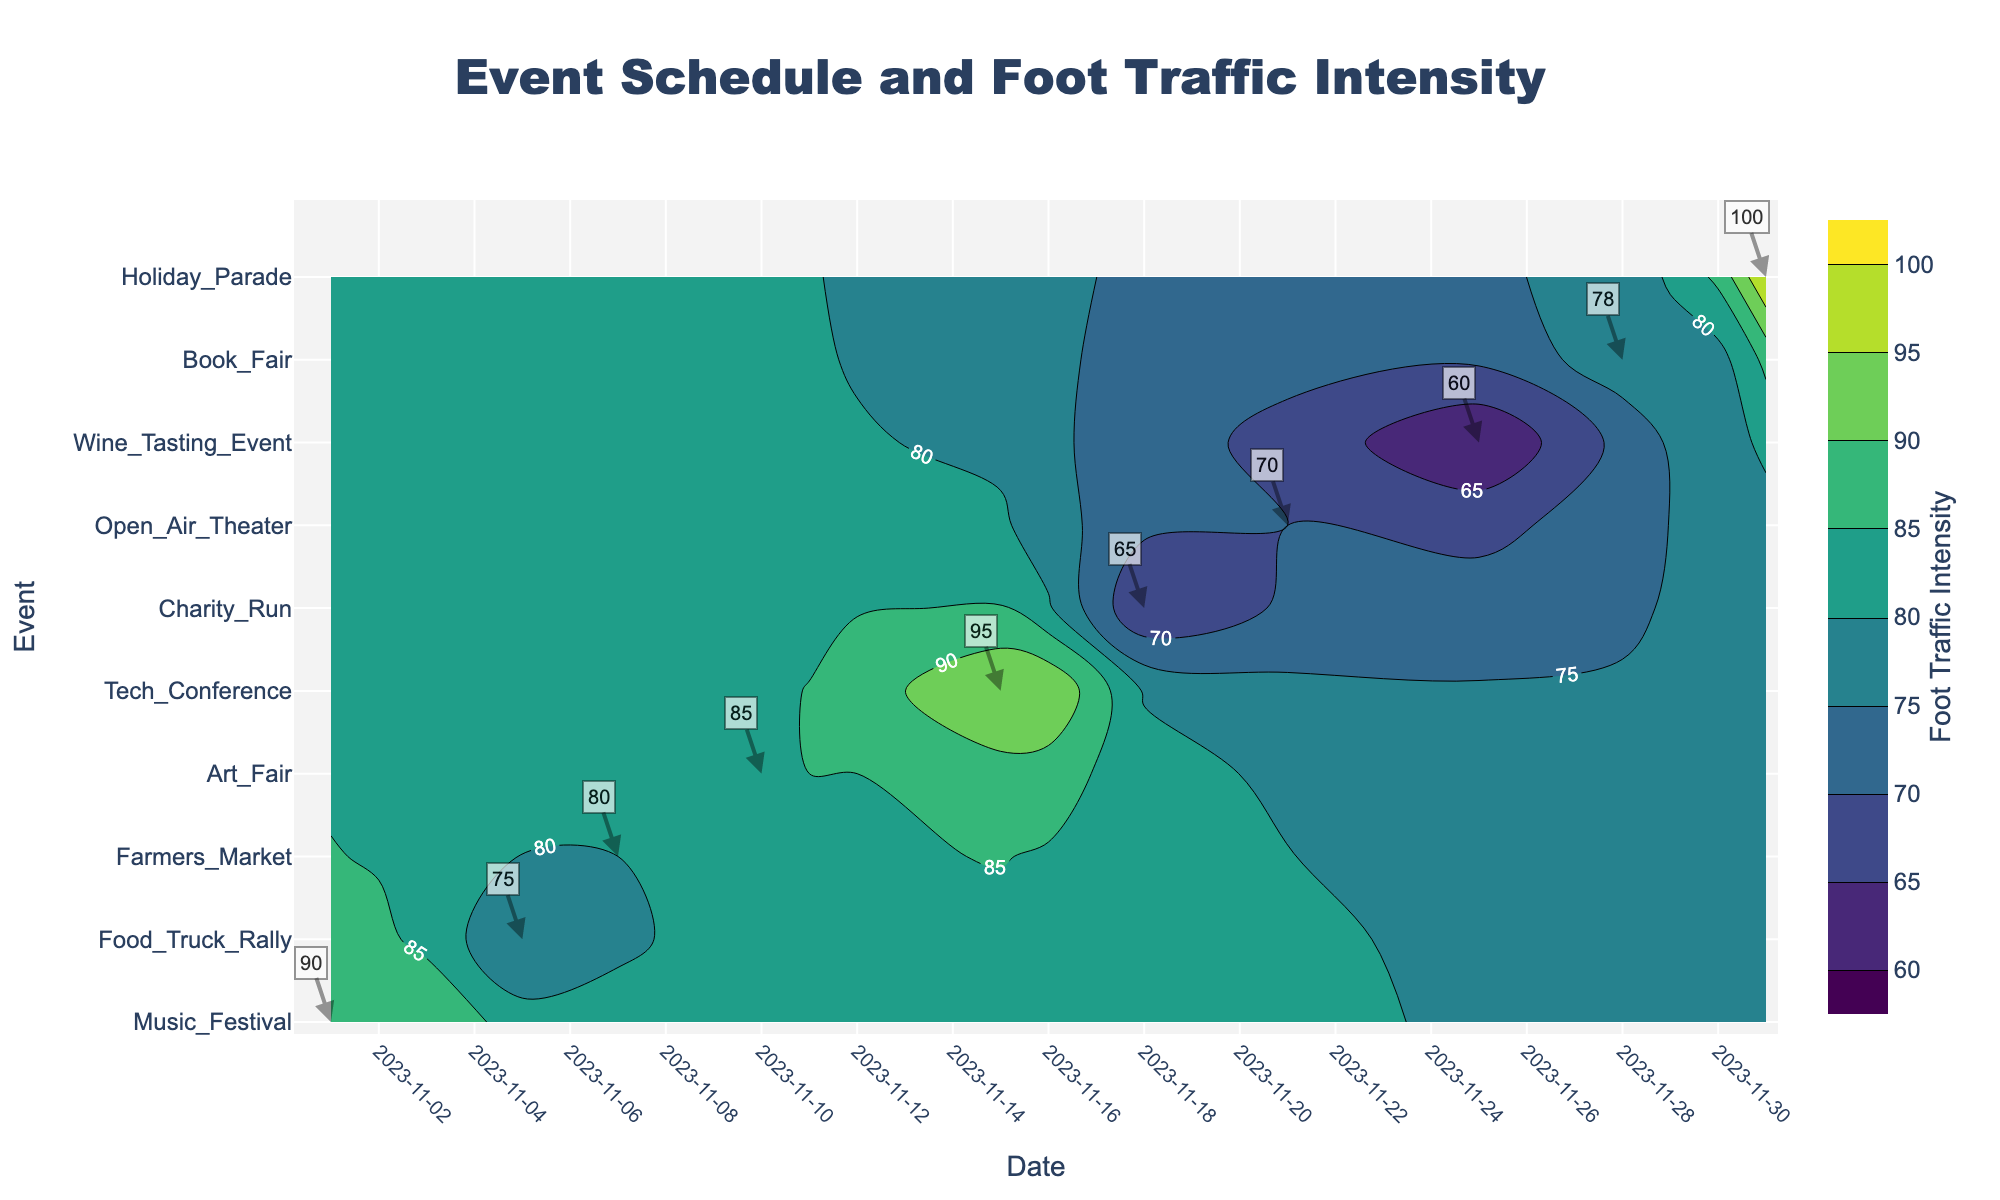What's the title of the plot? The title of the plot is located at the top center of the figure. It reads "Event Schedule and Foot Traffic Intensity."
Answer: Event Schedule and Foot Traffic Intensity What event has the highest foot traffic intensity? The contour plot labels the intensities for each event, and the highest number shown is 100 for the Holiday Parade.
Answer: Holiday Parade Which event lasts the longest? Look at the start and end dates on the x-axis for each event on the y-axis. The Book Fair spans the longest, from November 28 to November 30.
Answer: Book Fair What is the foot traffic intensity for the Tech Conference? Locate the Tech Conference on the y-axis and read the label directly on the contour plot. The foot traffic intensity for the Tech Conference is labeled as 95.
Answer: 95 Between the Music Festival and the Art Fair, which has a higher foot traffic intensity? Compare the foot traffic intensity labels for the Music Festival and the Art Fair on the contour plot. The Music Festival has an intensity of 90, whereas the Art Fair has an intensity of 85.
Answer: Music Festival On which date does the event with the lowest foot traffic intensity occur? Find the event with the lowest foot traffic intensity label on the contour plot, which is the Wine Tasting Event with an intensity of 60. It occurs on November 25.
Answer: November 25 What is the average foot traffic intensity of the events occurring in November? Add the intensities for all November events (90, 75, 80, 85, 95, 65, 70, 60, 78, 100) and divide by the number of events, which is 10. The sum is 798, and the average is 798 / 10 = 79.8
Answer: 79.8 Which event occurs closest to the Holiday Parade in time? Look for the event closest in date to December 1 on the x-axis. The closest event is the Book Fair, ending on November 30.
Answer: Book Fair Which event has a foot traffic intensity equal to 65? Find the intensity label 65 on the contour plot, which corresponds to the Charity Run.
Answer: Charity Run 